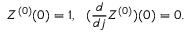Convert formula to latex. <formula><loc_0><loc_0><loc_500><loc_500>Z ^ { ( 0 ) } ( 0 ) = 1 , ( \frac { d } { d j } Z ^ { ( 0 ) } ) ( 0 ) = 0 .</formula> 